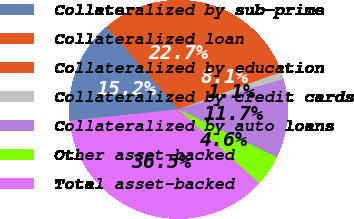Convert chart to OTSL. <chart><loc_0><loc_0><loc_500><loc_500><pie_chart><fcel>Collateralized by sub-prime<fcel>Collateralized loan<fcel>Collateralized by education<fcel>Collateralized by credit cards<fcel>Collateralized by auto loans<fcel>Other asset-backed<fcel>Total asset-backed<nl><fcel>15.24%<fcel>22.73%<fcel>8.15%<fcel>1.07%<fcel>11.7%<fcel>4.61%<fcel>36.5%<nl></chart> 